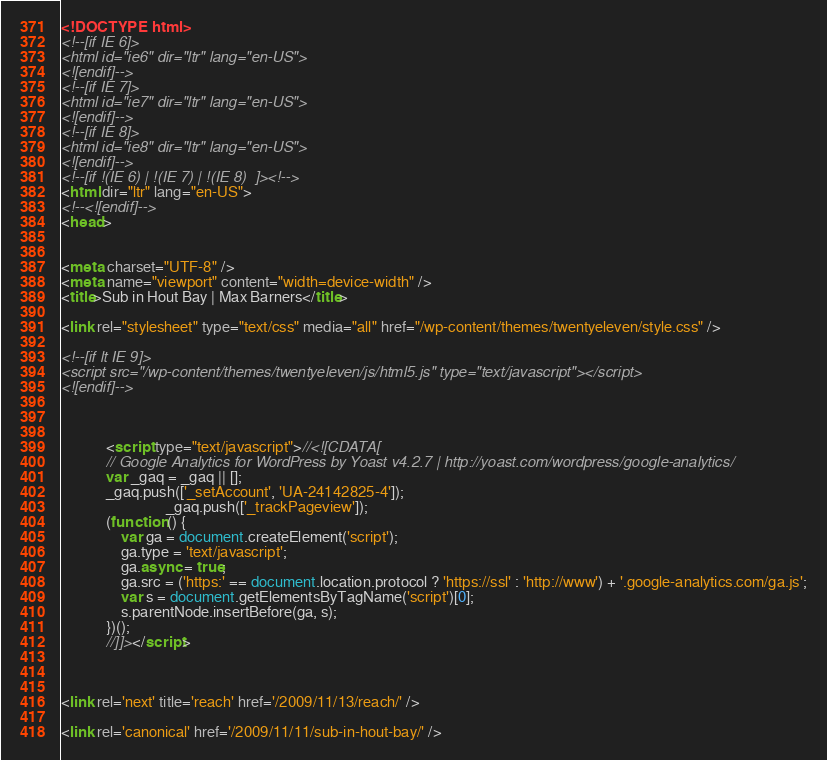Convert code to text. <code><loc_0><loc_0><loc_500><loc_500><_HTML_><!DOCTYPE html>
<!--[if IE 6]>
<html id="ie6" dir="ltr" lang="en-US">
<![endif]-->
<!--[if IE 7]>
<html id="ie7" dir="ltr" lang="en-US">
<![endif]-->
<!--[if IE 8]>
<html id="ie8" dir="ltr" lang="en-US">
<![endif]-->
<!--[if !(IE 6) | !(IE 7) | !(IE 8)  ]><!-->
<html dir="ltr" lang="en-US">
<!--<![endif]-->
<head>


<meta charset="UTF-8" />
<meta name="viewport" content="width=device-width" />
<title>Sub in Hout Bay | Max Barners</title>

<link rel="stylesheet" type="text/css" media="all" href="/wp-content/themes/twentyeleven/style.css" />

<!--[if lt IE 9]>
<script src="/wp-content/themes/twentyeleven/js/html5.js" type="text/javascript"></script>
<![endif]-->



			<script type="text/javascript">//<![CDATA[
			// Google Analytics for WordPress by Yoast v4.2.7 | http://yoast.com/wordpress/google-analytics/
			var _gaq = _gaq || [];
			_gaq.push(['_setAccount', 'UA-24142825-4']);
							_gaq.push(['_trackPageview']);
			(function () {
				var ga = document.createElement('script');
				ga.type = 'text/javascript';
				ga.async = true;
				ga.src = ('https:' == document.location.protocol ? 'https://ssl' : 'http://www') + '.google-analytics.com/ga.js';
				var s = document.getElementsByTagName('script')[0];
				s.parentNode.insertBefore(ga, s);
			})();
			//]]></script>
			
 

<link rel='next' title='reach' href='/2009/11/13/reach/' />

<link rel='canonical' href='/2009/11/11/sub-in-hout-bay/' /></code> 